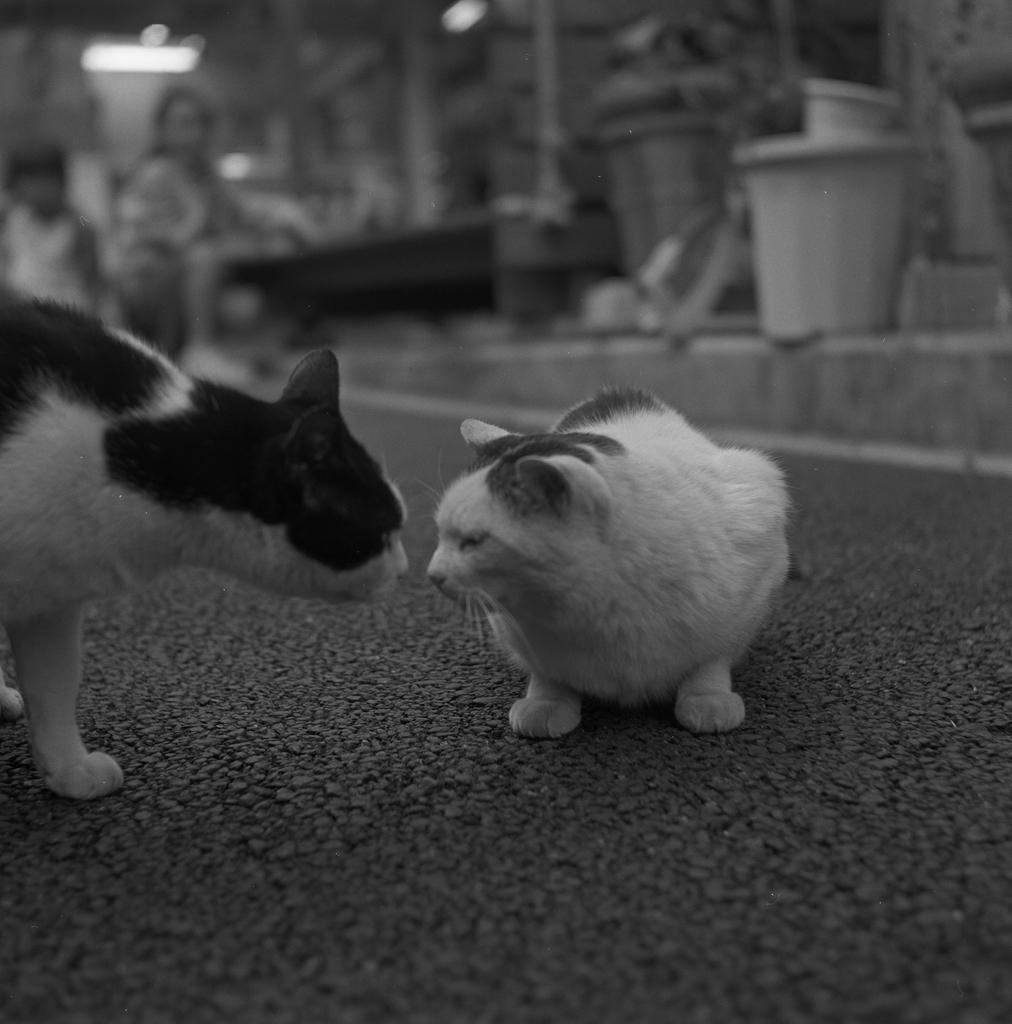How would you summarize this image in a sentence or two? It is a black and white image and in the picture there are two cats facing each other and the background of the cats is blur. 